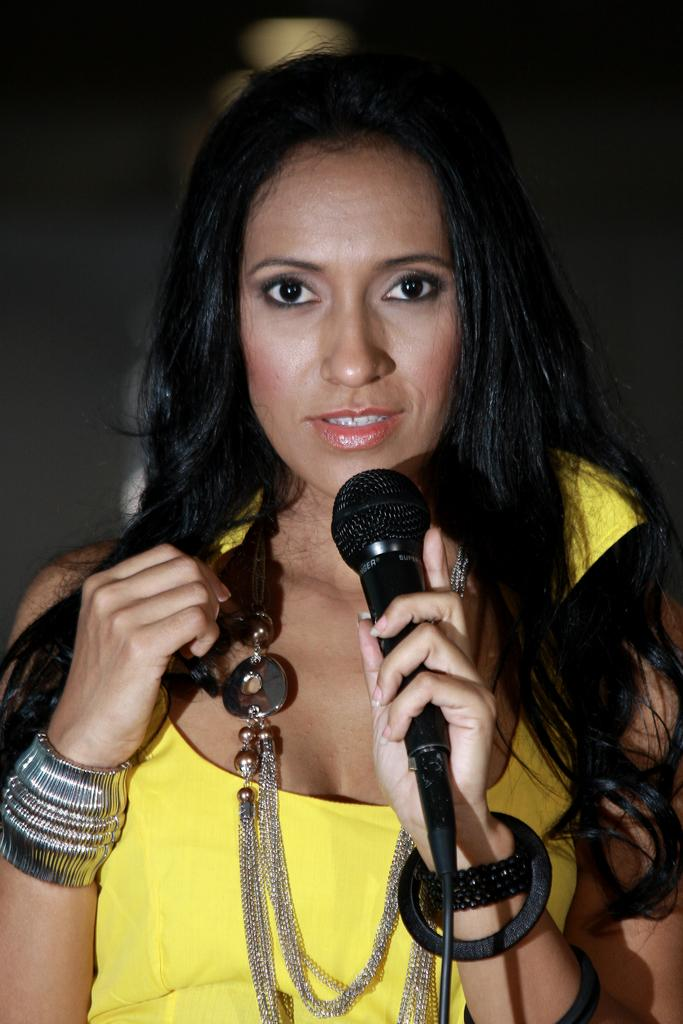Who is the main subject in the image? There is a lady in the image. What is the lady wearing? The lady is wearing a yellow dress. What is the lady holding in the image? The lady is holding a mic. Are there any accessories visible on the lady? Yes, the lady has chains around her neck. How many mice can be seen hiding in the lady's dress in the image? There are no mice visible in the image, as the lady is wearing a yellow dress. What type of locket is hanging from the chains around the lady's neck? There is no locket mentioned or visible in the image; the lady is wearing chains around her neck. 